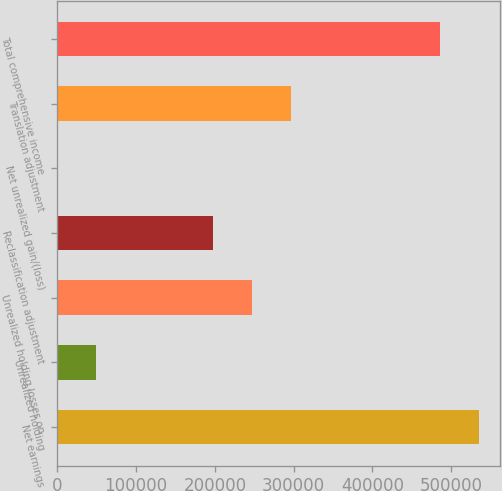Convert chart to OTSL. <chart><loc_0><loc_0><loc_500><loc_500><bar_chart><fcel>Net earnings<fcel>Unrealized holding<fcel>Unrealized holding losses on<fcel>Reclassification adjustment<fcel>Net unrealized gain/(loss)<fcel>Translation adjustment<fcel>Total comprehensive income<nl><fcel>535445<fcel>49752<fcel>247360<fcel>197958<fcel>350<fcel>296762<fcel>486043<nl></chart> 